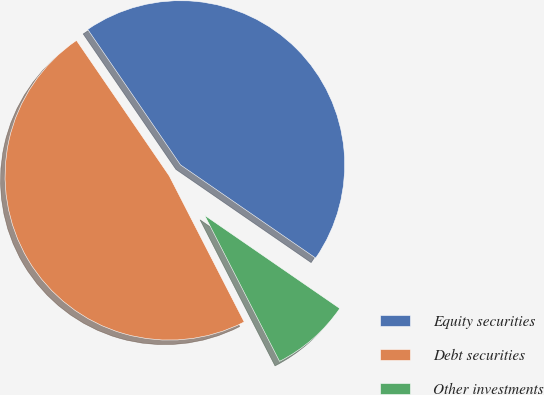Convert chart to OTSL. <chart><loc_0><loc_0><loc_500><loc_500><pie_chart><fcel>Equity securities<fcel>Debt securities<fcel>Other investments<nl><fcel>44.16%<fcel>47.99%<fcel>7.85%<nl></chart> 